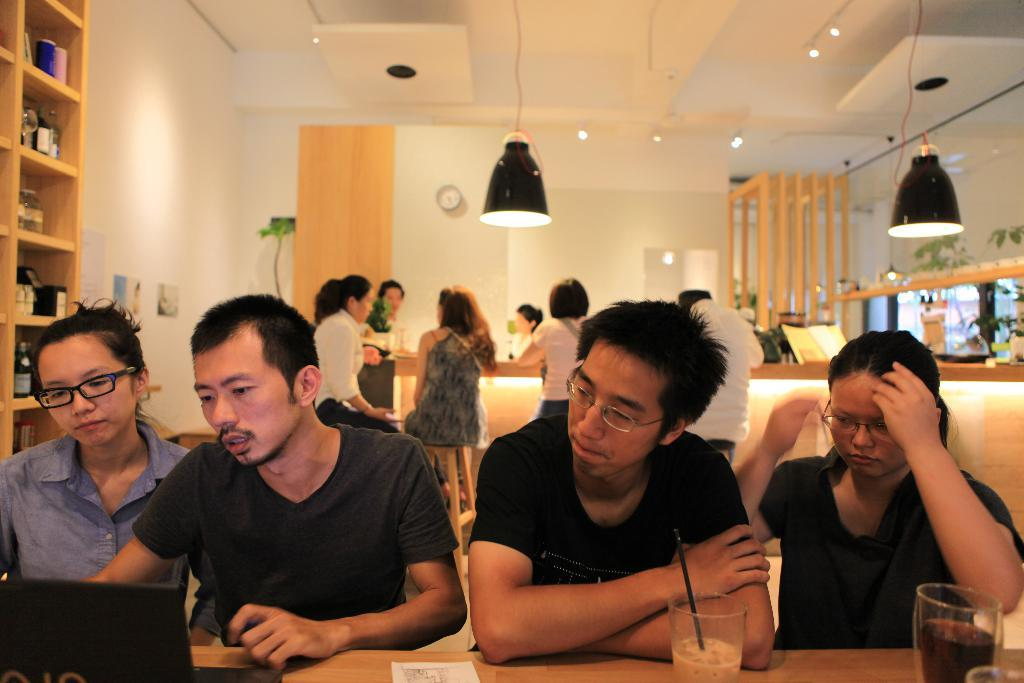What is the color of the wall in the image? The wall in the image is white. How many lights can be seen in the image? There are two lights in the image. What time-keeping device is present in the image? There is a clock in the image. What piece of furniture is in the image? There is a table in the image. What items are on the table? There are glasses and a laptop on the table. What type of canvas is being painted on the bed in the image? There is no canvas or bed present in the image; it features a white wall, two lights, a clock, a table, glasses, and a laptop. 